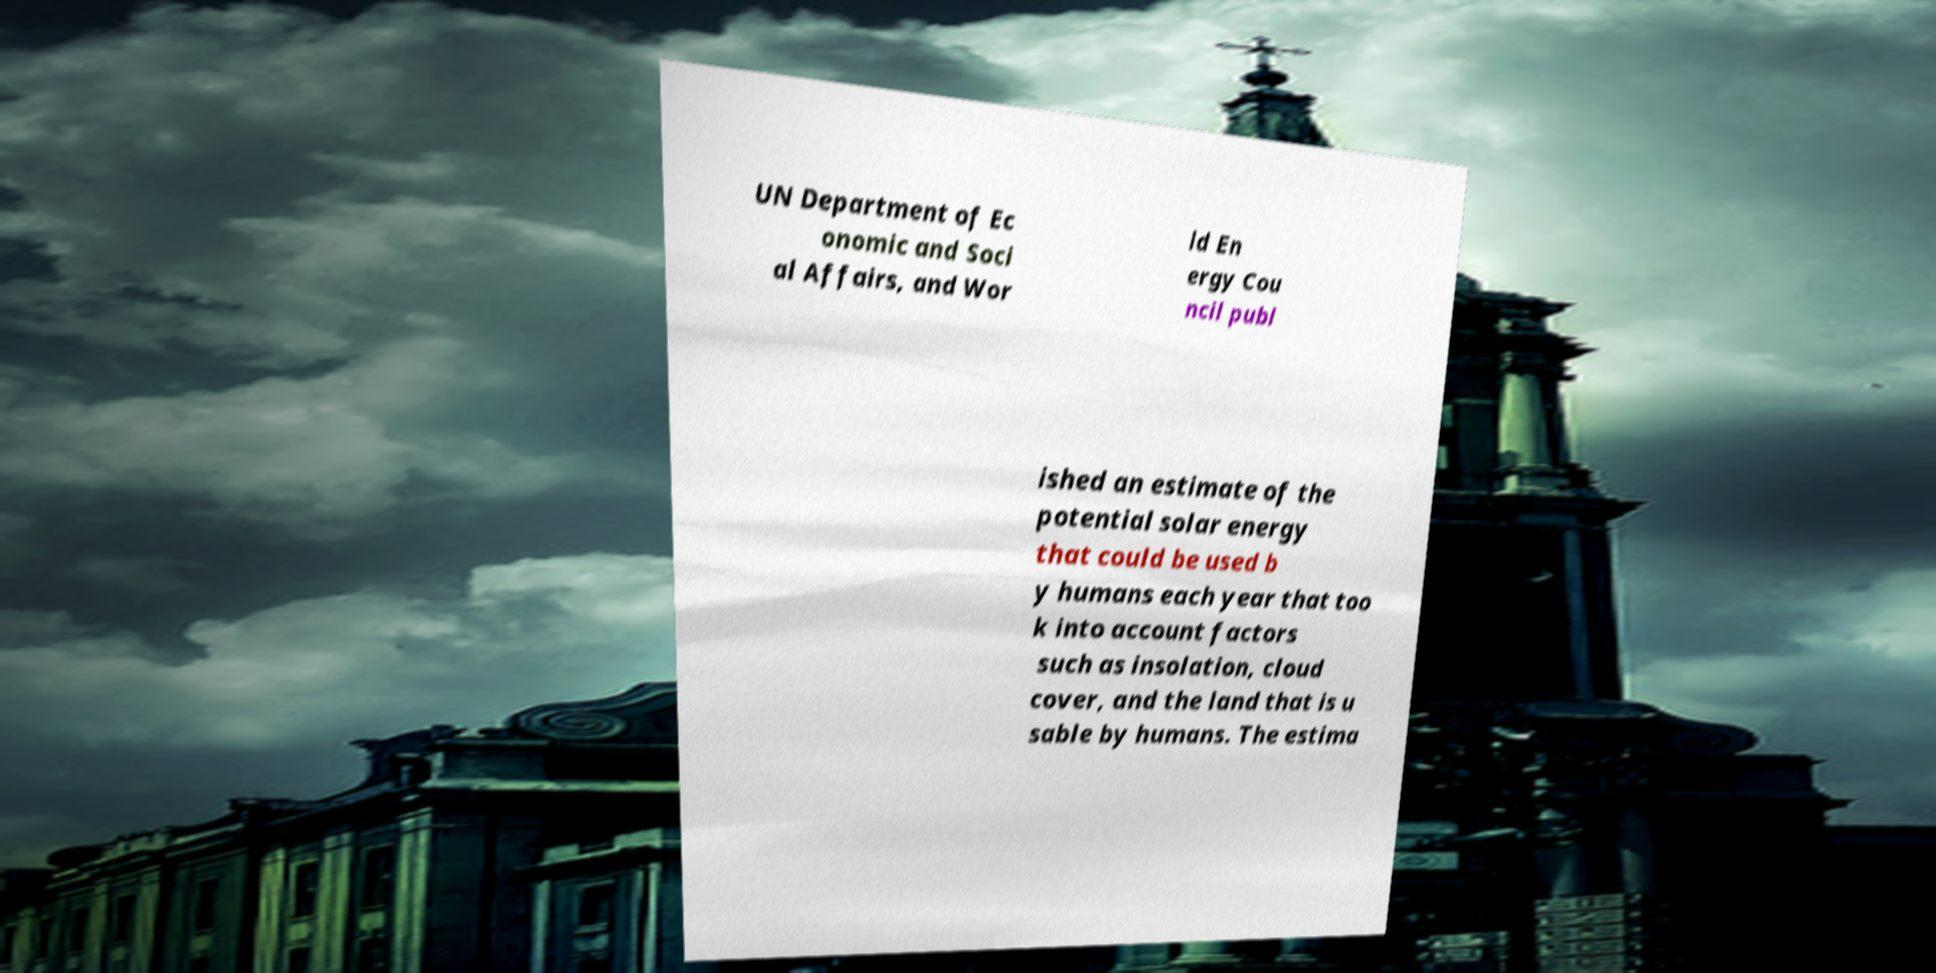For documentation purposes, I need the text within this image transcribed. Could you provide that? UN Department of Ec onomic and Soci al Affairs, and Wor ld En ergy Cou ncil publ ished an estimate of the potential solar energy that could be used b y humans each year that too k into account factors such as insolation, cloud cover, and the land that is u sable by humans. The estima 